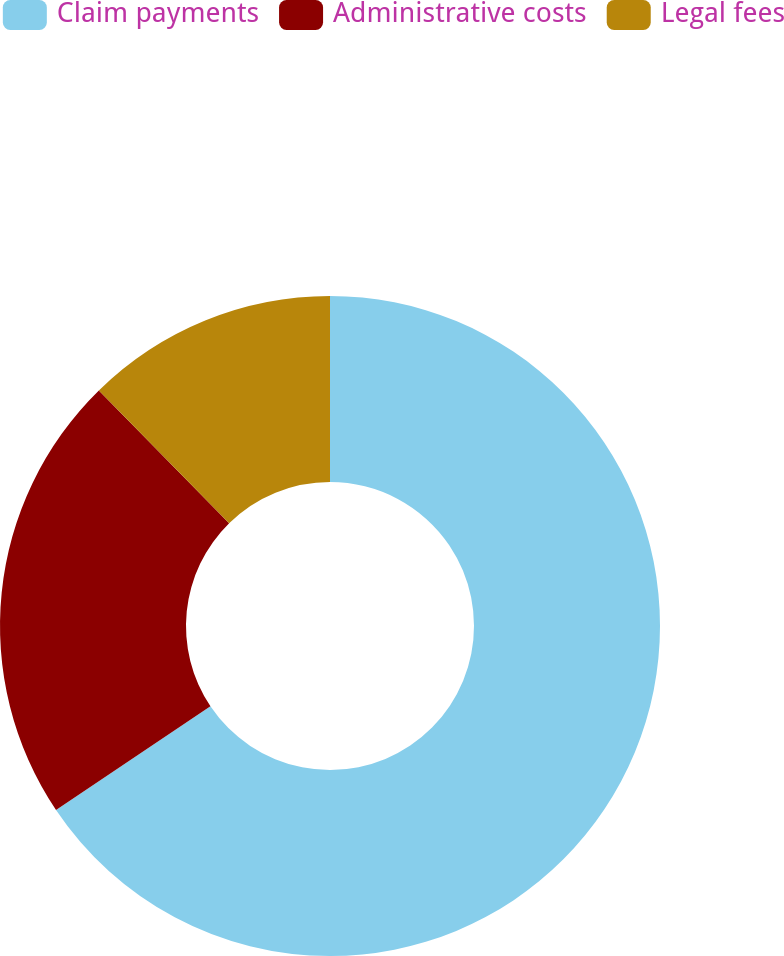<chart> <loc_0><loc_0><loc_500><loc_500><pie_chart><fcel>Claim payments<fcel>Administrative costs<fcel>Legal fees<nl><fcel>65.59%<fcel>22.06%<fcel>12.35%<nl></chart> 